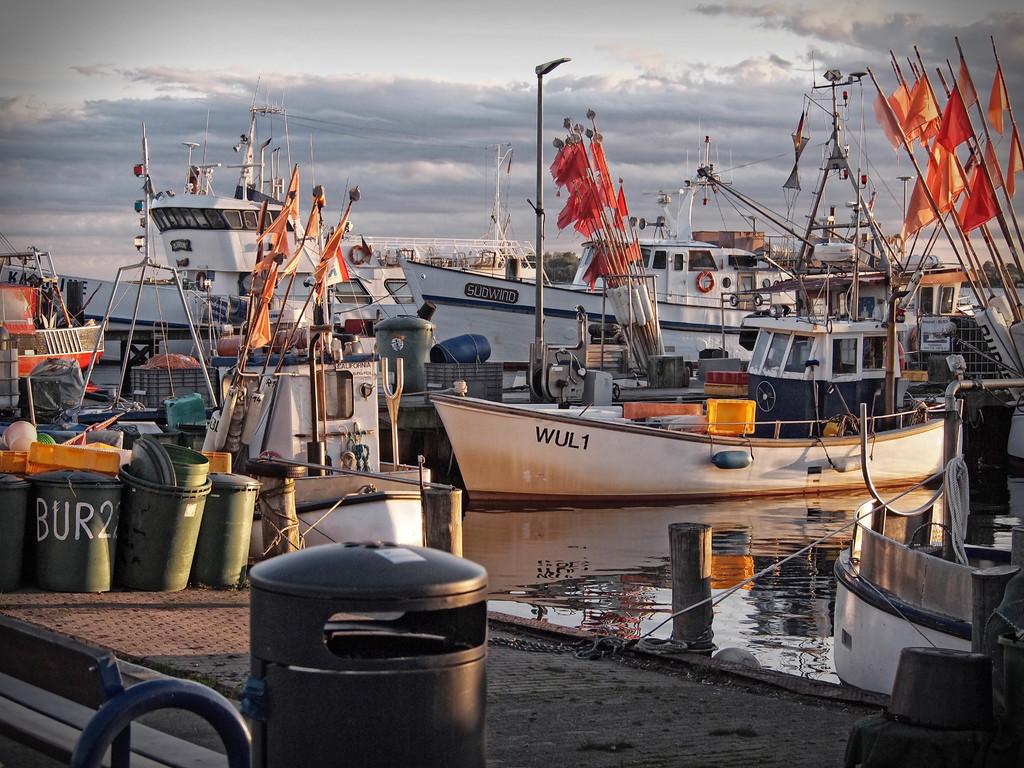What is the name of the boat closest to the camera?
Make the answer very short. Wul1. What is written across the garbage bin?
Give a very brief answer. Bur2. 